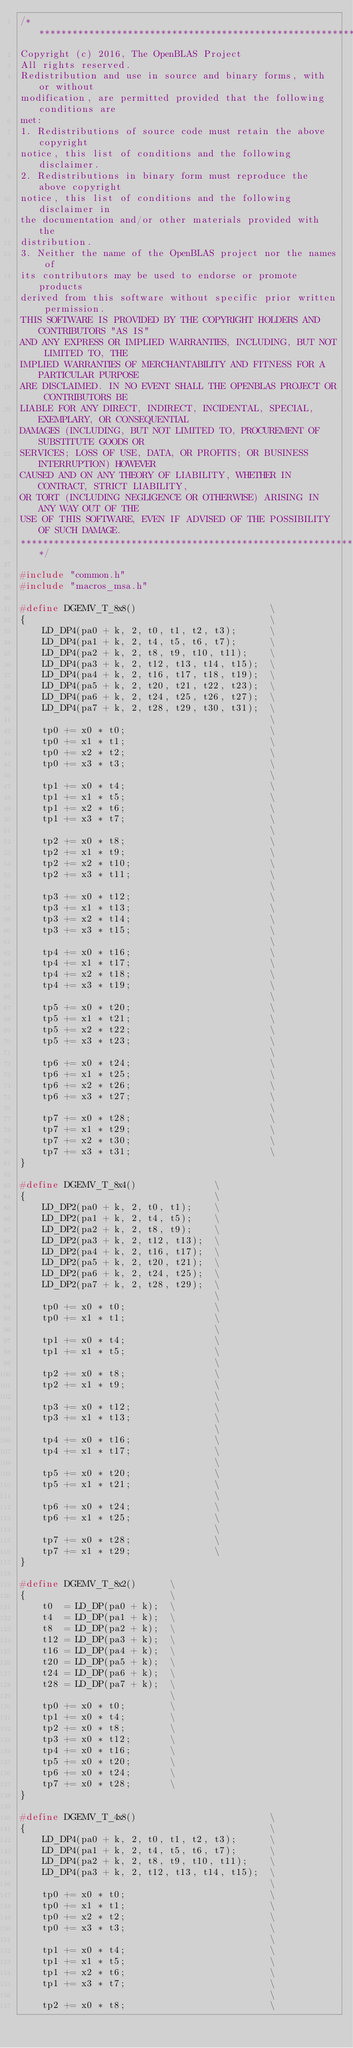Convert code to text. <code><loc_0><loc_0><loc_500><loc_500><_C_>/*******************************************************************************
Copyright (c) 2016, The OpenBLAS Project
All rights reserved.
Redistribution and use in source and binary forms, with or without
modification, are permitted provided that the following conditions are
met:
1. Redistributions of source code must retain the above copyright
notice, this list of conditions and the following disclaimer.
2. Redistributions in binary form must reproduce the above copyright
notice, this list of conditions and the following disclaimer in
the documentation and/or other materials provided with the
distribution.
3. Neither the name of the OpenBLAS project nor the names of
its contributors may be used to endorse or promote products
derived from this software without specific prior written permission.
THIS SOFTWARE IS PROVIDED BY THE COPYRIGHT HOLDERS AND CONTRIBUTORS "AS IS"
AND ANY EXPRESS OR IMPLIED WARRANTIES, INCLUDING, BUT NOT LIMITED TO, THE
IMPLIED WARRANTIES OF MERCHANTABILITY AND FITNESS FOR A PARTICULAR PURPOSE
ARE DISCLAIMED. IN NO EVENT SHALL THE OPENBLAS PROJECT OR CONTRIBUTORS BE
LIABLE FOR ANY DIRECT, INDIRECT, INCIDENTAL, SPECIAL, EXEMPLARY, OR CONSEQUENTIAL
DAMAGES (INCLUDING, BUT NOT LIMITED TO, PROCUREMENT OF SUBSTITUTE GOODS OR
SERVICES; LOSS OF USE, DATA, OR PROFITS; OR BUSINESS INTERRUPTION) HOWEVER
CAUSED AND ON ANY THEORY OF LIABILITY, WHETHER IN CONTRACT, STRICT LIABILITY,
OR TORT (INCLUDING NEGLIGENCE OR OTHERWISE) ARISING IN ANY WAY OUT OF THE
USE OF THIS SOFTWARE, EVEN IF ADVISED OF THE POSSIBILITY OF SUCH DAMAGE.
*******************************************************************************/

#include "common.h"
#include "macros_msa.h"

#define DGEMV_T_8x8()                        \
{                                            \
    LD_DP4(pa0 + k, 2, t0, t1, t2, t3);      \
    LD_DP4(pa1 + k, 2, t4, t5, t6, t7);      \
    LD_DP4(pa2 + k, 2, t8, t9, t10, t11);    \
    LD_DP4(pa3 + k, 2, t12, t13, t14, t15);  \
    LD_DP4(pa4 + k, 2, t16, t17, t18, t19);  \
    LD_DP4(pa5 + k, 2, t20, t21, t22, t23);  \
    LD_DP4(pa6 + k, 2, t24, t25, t26, t27);  \
    LD_DP4(pa7 + k, 2, t28, t29, t30, t31);  \
                                             \
    tp0 += x0 * t0;                          \
    tp0 += x1 * t1;                          \
    tp0 += x2 * t2;                          \
    tp0 += x3 * t3;                          \
                                             \
    tp1 += x0 * t4;                          \
    tp1 += x1 * t5;                          \
    tp1 += x2 * t6;                          \
    tp1 += x3 * t7;                          \
                                             \
    tp2 += x0 * t8;                          \
    tp2 += x1 * t9;                          \
    tp2 += x2 * t10;                         \
    tp2 += x3 * t11;                         \
                                             \
    tp3 += x0 * t12;                         \
    tp3 += x1 * t13;                         \
    tp3 += x2 * t14;                         \
    tp3 += x3 * t15;                         \
                                             \
    tp4 += x0 * t16;                         \
    tp4 += x1 * t17;                         \
    tp4 += x2 * t18;                         \
    tp4 += x3 * t19;                         \
                                             \
    tp5 += x0 * t20;                         \
    tp5 += x1 * t21;                         \
    tp5 += x2 * t22;                         \
    tp5 += x3 * t23;                         \
                                             \
    tp6 += x0 * t24;                         \
    tp6 += x1 * t25;                         \
    tp6 += x2 * t26;                         \
    tp6 += x3 * t27;                         \
                                             \
    tp7 += x0 * t28;                         \
    tp7 += x1 * t29;                         \
    tp7 += x2 * t30;                         \
    tp7 += x3 * t31;                         \
}

#define DGEMV_T_8x4()              \
{                                  \
    LD_DP2(pa0 + k, 2, t0, t1);    \
    LD_DP2(pa1 + k, 2, t4, t5);    \
    LD_DP2(pa2 + k, 2, t8, t9);    \
    LD_DP2(pa3 + k, 2, t12, t13);  \
    LD_DP2(pa4 + k, 2, t16, t17);  \
    LD_DP2(pa5 + k, 2, t20, t21);  \
    LD_DP2(pa6 + k, 2, t24, t25);  \
    LD_DP2(pa7 + k, 2, t28, t29);  \
                                   \
    tp0 += x0 * t0;                \
    tp0 += x1 * t1;                \
                                   \
    tp1 += x0 * t4;                \
    tp1 += x1 * t5;                \
                                   \
    tp2 += x0 * t8;                \
    tp2 += x1 * t9;                \
                                   \
    tp3 += x0 * t12;               \
    tp3 += x1 * t13;               \
                                   \
    tp4 += x0 * t16;               \
    tp4 += x1 * t17;               \
                                   \
    tp5 += x0 * t20;               \
    tp5 += x1 * t21;               \
                                   \
    tp6 += x0 * t24;               \
    tp6 += x1 * t25;               \
                                   \
    tp7 += x0 * t28;               \
    tp7 += x1 * t29;               \
}

#define DGEMV_T_8x2()      \
{                          \
    t0  = LD_DP(pa0 + k);  \
    t4  = LD_DP(pa1 + k);  \
    t8  = LD_DP(pa2 + k);  \
    t12 = LD_DP(pa3 + k);  \
    t16 = LD_DP(pa4 + k);  \
    t20 = LD_DP(pa5 + k);  \
    t24 = LD_DP(pa6 + k);  \
    t28 = LD_DP(pa7 + k);  \
                           \
    tp0 += x0 * t0;        \
    tp1 += x0 * t4;        \
    tp2 += x0 * t8;        \
    tp3 += x0 * t12;       \
    tp4 += x0 * t16;       \
    tp5 += x0 * t20;       \
    tp6 += x0 * t24;       \
    tp7 += x0 * t28;       \
}

#define DGEMV_T_4x8()                        \
{                                            \
    LD_DP4(pa0 + k, 2, t0, t1, t2, t3);      \
    LD_DP4(pa1 + k, 2, t4, t5, t6, t7);      \
    LD_DP4(pa2 + k, 2, t8, t9, t10, t11);    \
    LD_DP4(pa3 + k, 2, t12, t13, t14, t15);  \
                                             \
    tp0 += x0 * t0;                          \
    tp0 += x1 * t1;                          \
    tp0 += x2 * t2;                          \
    tp0 += x3 * t3;                          \
                                             \
    tp1 += x0 * t4;                          \
    tp1 += x1 * t5;                          \
    tp1 += x2 * t6;                          \
    tp1 += x3 * t7;                          \
                                             \
    tp2 += x0 * t8;                          \</code> 